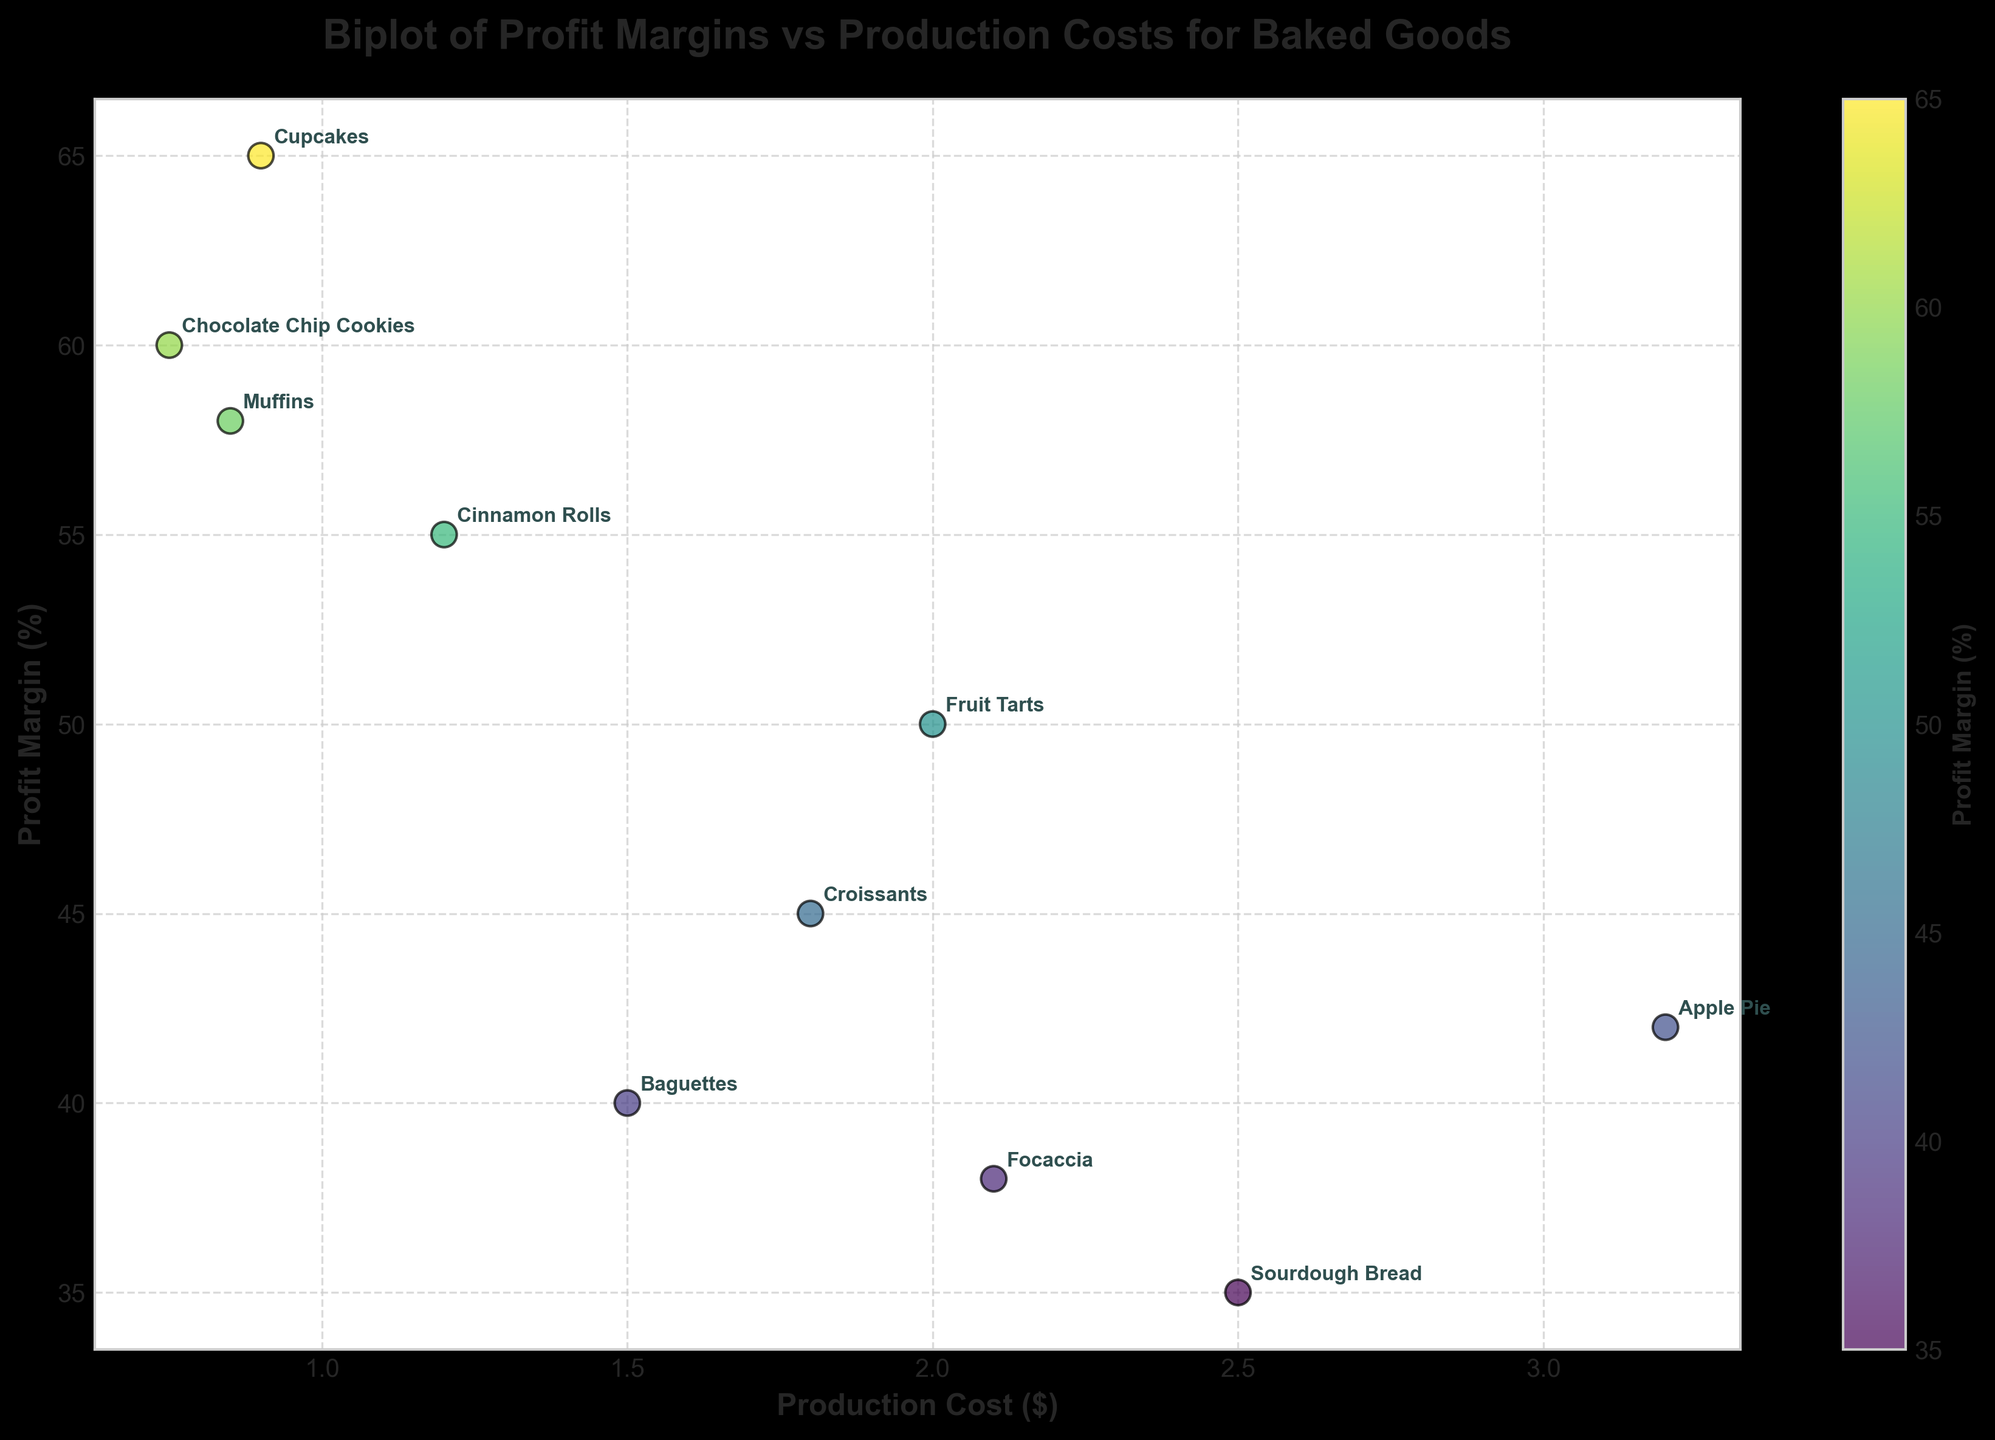What is the title of the figure? The title of the figure is at the top of the plot and reads "Biplot of Profit Margins vs Production Costs for Baked Goods."
Answer: Biplot of Profit Margins vs Production Costs for Baked Goods Which product has the highest profit margin? By looking at the y-axis (Profit Margin %) and finding the highest point on the scatter plot, we see that "Cupcakes" has the highest profit margin.
Answer: Cupcakes What are the labels of the x-axis and y-axis? The labels of the axes are found on the respective sides of the plot: the x-axis label is "Production Cost ($)" and the y-axis label is "Profit Margin (%)".
Answer: Production Cost ($) and Profit Margin (%) How many products are displayed in the biplot? We can count the number of scatter points or the number of annotations on the plot. There are 10 products displayed.
Answer: 10 Which product has the lowest production cost? By looking at the x-axis (Production Cost $) and finding the leftmost point, we see that "Chocolate Chip Cookies" has the lowest production cost.
Answer: Chocolate Chip Cookies Compare the profit margins of Sourdough Bread and Focaccia. Which one is higher and by how much? Locate "Sourdough Bread" and "Focaccia" on the scatter plot. Sourdough Bread has a profit margin of 35%, and Focaccia has a profit margin of 38%. The difference is 38% - 35% = 3%.
Answer: Focaccia by 3% What is the average production cost of Croissants and Fruit Tarts? Find the production cost values for Croissants ($1.80) and Fruit Tarts ($2.00). Calculate the average: (1.80 + 2.00) / 2 = $1.90.
Answer: $1.90 Which product is both more expensive to produce and has a higher profit margin compared to Baguettes? Find Baguettes in the scatter plot, which has a production cost of $1.50 and a profit margin of 40%. Identify products with both higher values. "Apple Pie" has a production cost of $3.20 and a profit margin of 42%.
Answer: Apple Pie If a product has a production cost below $1, is its profit margin always above 50%? Identify products with production costs below $1 (Chocolate Chip Cookies and Muffins). Their profit margins are 60% and 58%, respectively, which are both above 50%.
Answer: Yes What is the color scale in the plot representing? The color scale represents the profit margin percentages, indicated by the color bar on the right side of the plot.
Answer: Profit Margin (%) 